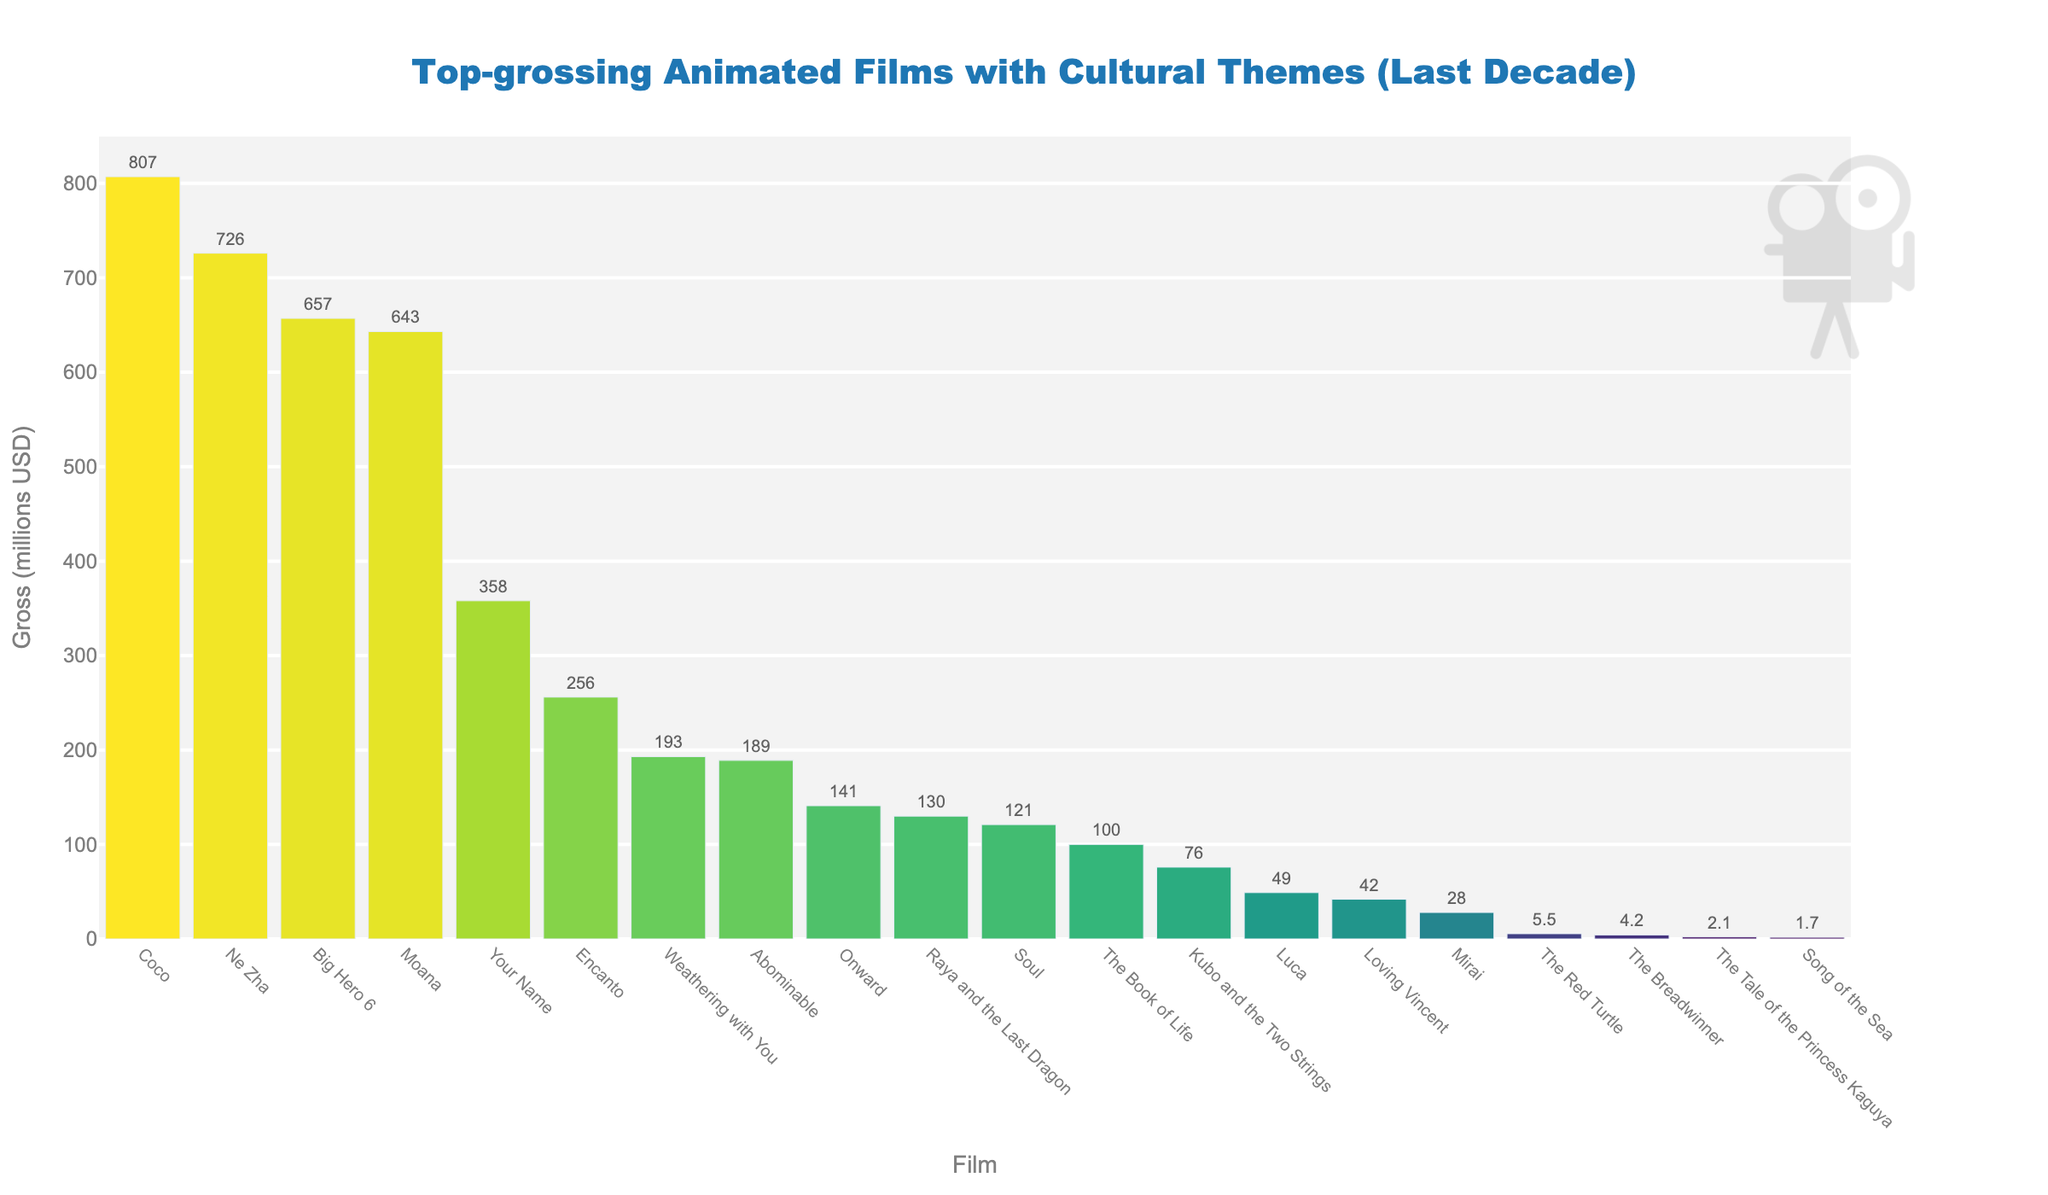Which film has the highest gross in millions USD? The highest bar in the chart corresponds to the film "Coco" with a gross of 807 million USD.
Answer: Coco How much higher is the gross of "Coco" compared to "Moana"? The gross of "Coco" is 807 million USD and the gross of "Moana" is 643 million USD. The difference is 807 - 643 = 164 million USD.
Answer: 164 million USD Which film has the lowest gross among the listed films? The lowest bar in the chart corresponds to the film "Song of the Sea" with a gross of 1.7 million USD.
Answer: Song of the Sea What is the difference in gross between "Ne Zha" and "Big Hero 6"? The gross of "Ne Zha" is 726 million USD and the gross of "Big Hero 6" is 657 million USD. The difference is 726 - 657 = 69 million USD.
Answer: 69 million USD Which film has a gross closest to 200 million USD? The bar closest to the 200 million USD line is "Weathering with You" with a gross of 193 million USD.
Answer: Weathering with You What is the total gross of the films with a gross over 500 million USD? The films with a gross over 500 million USD are "Coco" (807), "Ne Zha" (726), "Big Hero 6" (657), and "Moana" (643). The total gross is 807 + 726 + 657 + 643 = 2833 million USD.
Answer: 2833 million USD Which films have a gross less than "The Tale of the Princess Kaguya"? The gross of "The Tale of the Princess Kaguya" is 2.1 million USD. The films with a lower gross are "Song of the Sea" and "The Breadwinner".
Answer: Song of the Sea, The Breadwinner How many films have a gross below 100 million USD? Films with a gross below 100 million USD are "Kubo and the Two Strings" (76), "The Book of Life" (100), "Song of the Sea" (1.7), "The Tale of the Princess Kaguya" (2.1), "The Red Turtle" (5.5), "Loving Vincent" (42), "Mirai" (28), and "Luca" (49).
Answer: 8 What is the average gross of all the films listed? Sum the gross values of all films and divide by the number of films: (807 + 643 + 657 + 130 + 76 + 726 + 189 + 100 + 1.7 + 2.1 + 5.5 + 42 + 358 + 4.2 + 28 + 193 + 141 + 121 + 49 + 256) / 20 = 4129.5 / 20 = 206.475 million USD.
Answer: 206.475 million USD Which film has the second highest gross? The second highest bar in the chart corresponds to the film "Ne Zha" with a gross of 726 million USD.
Answer: Ne Zha 